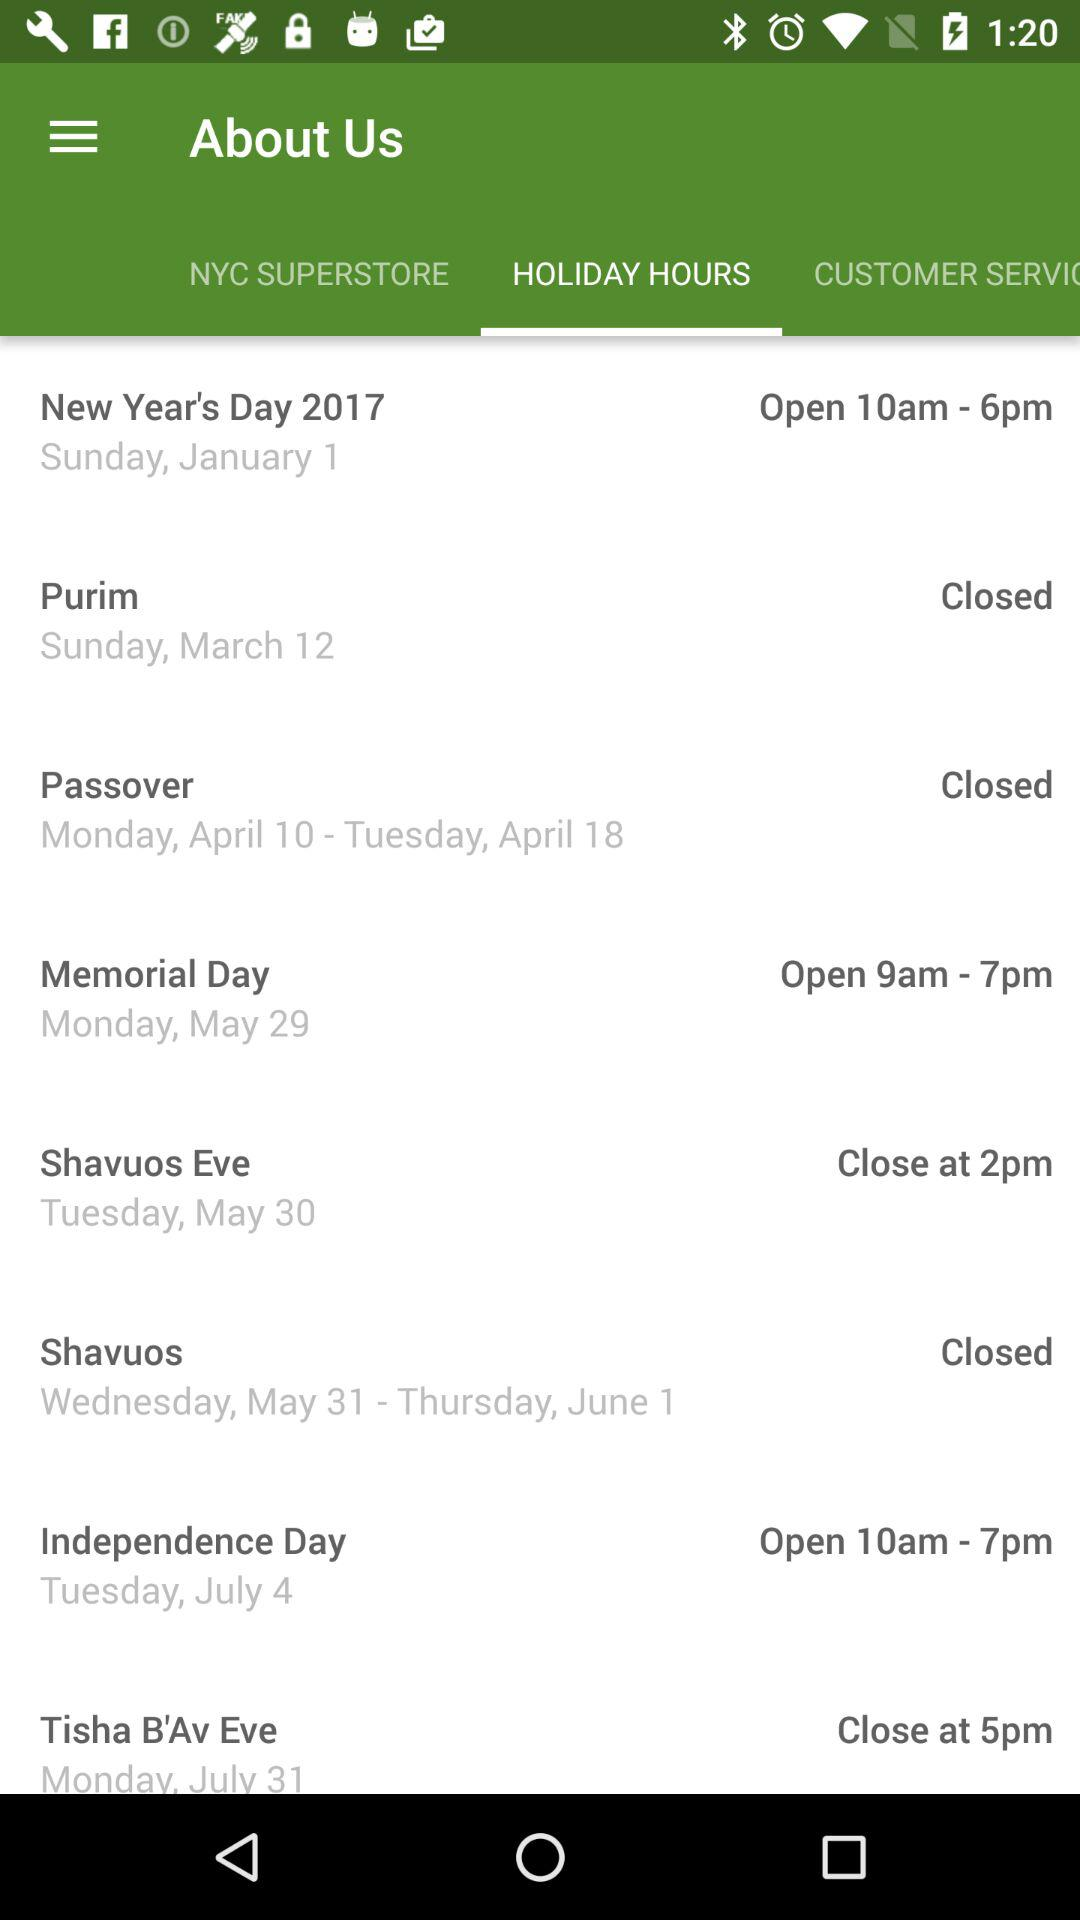Which tab has been selected? The tab "HOLIDAY HOURS" has been selected. 